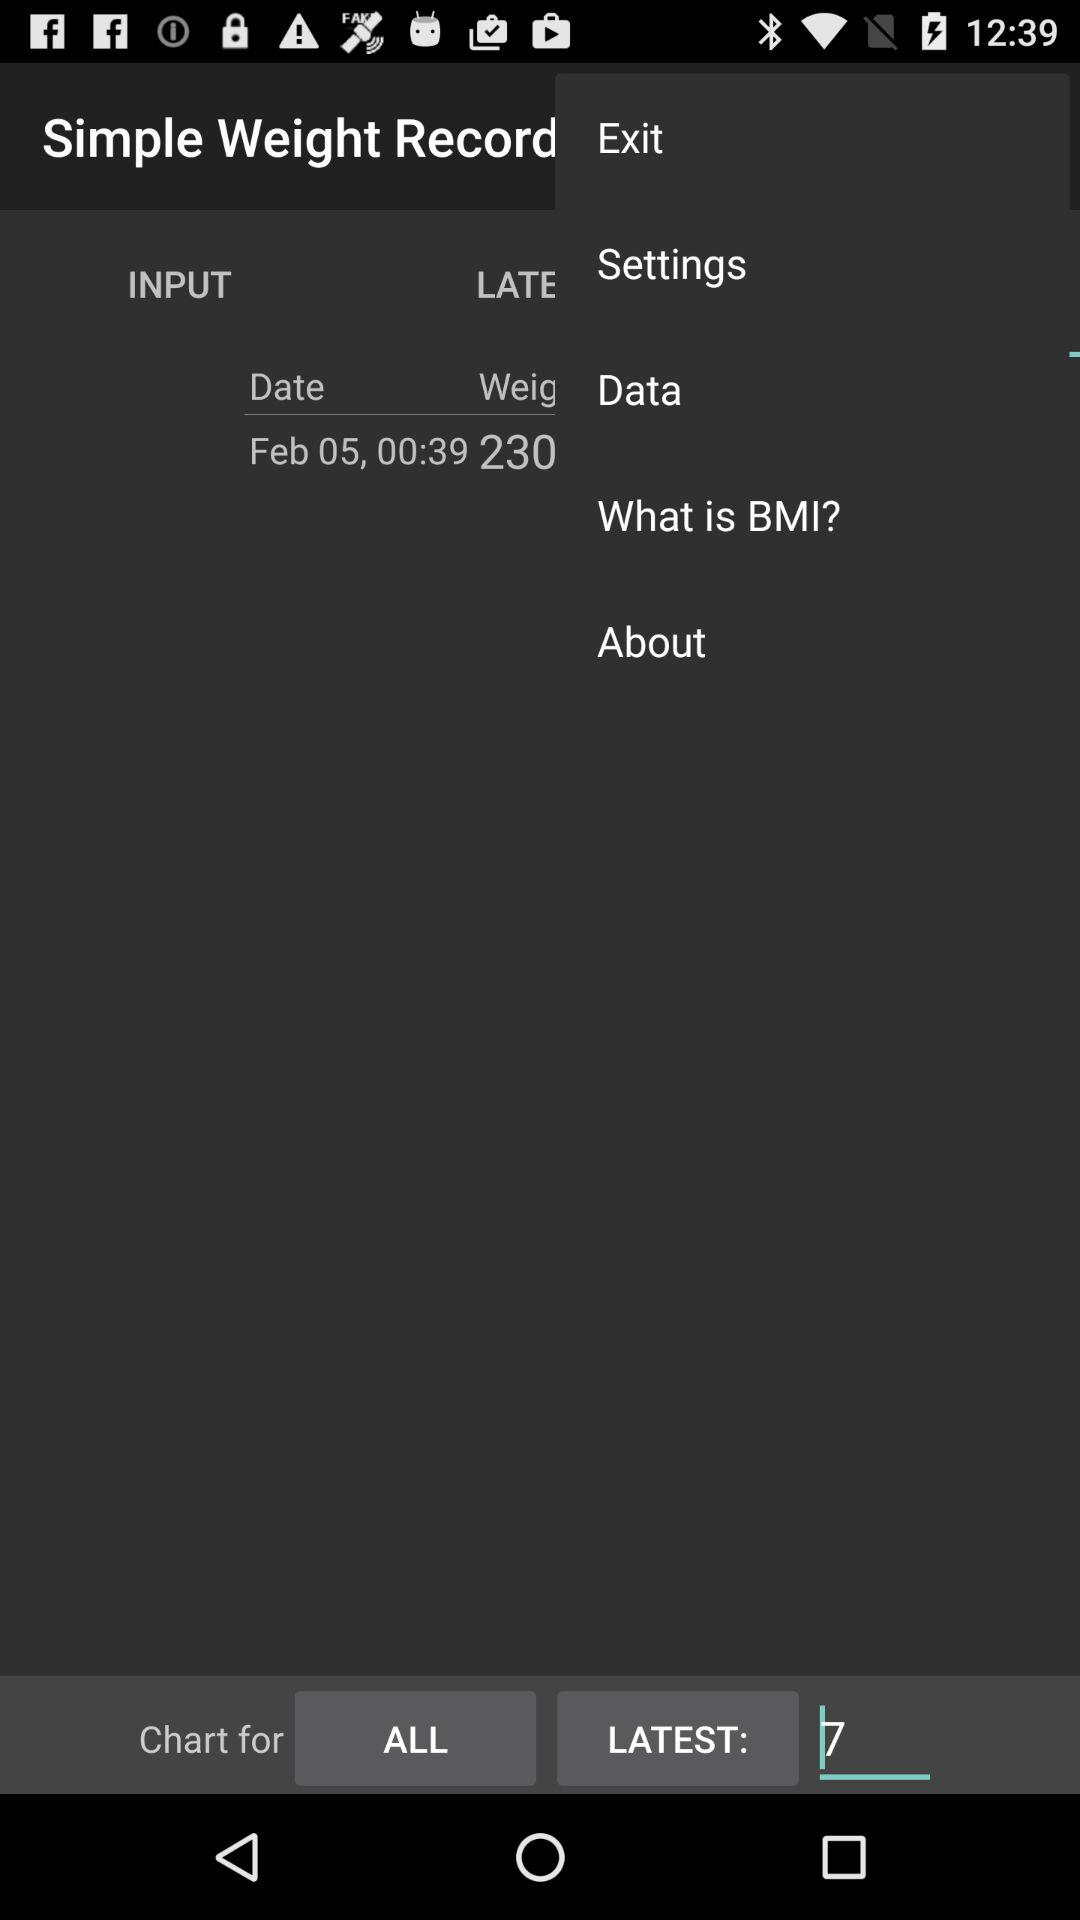What is the total number for the latest chart? The total number is 7. 